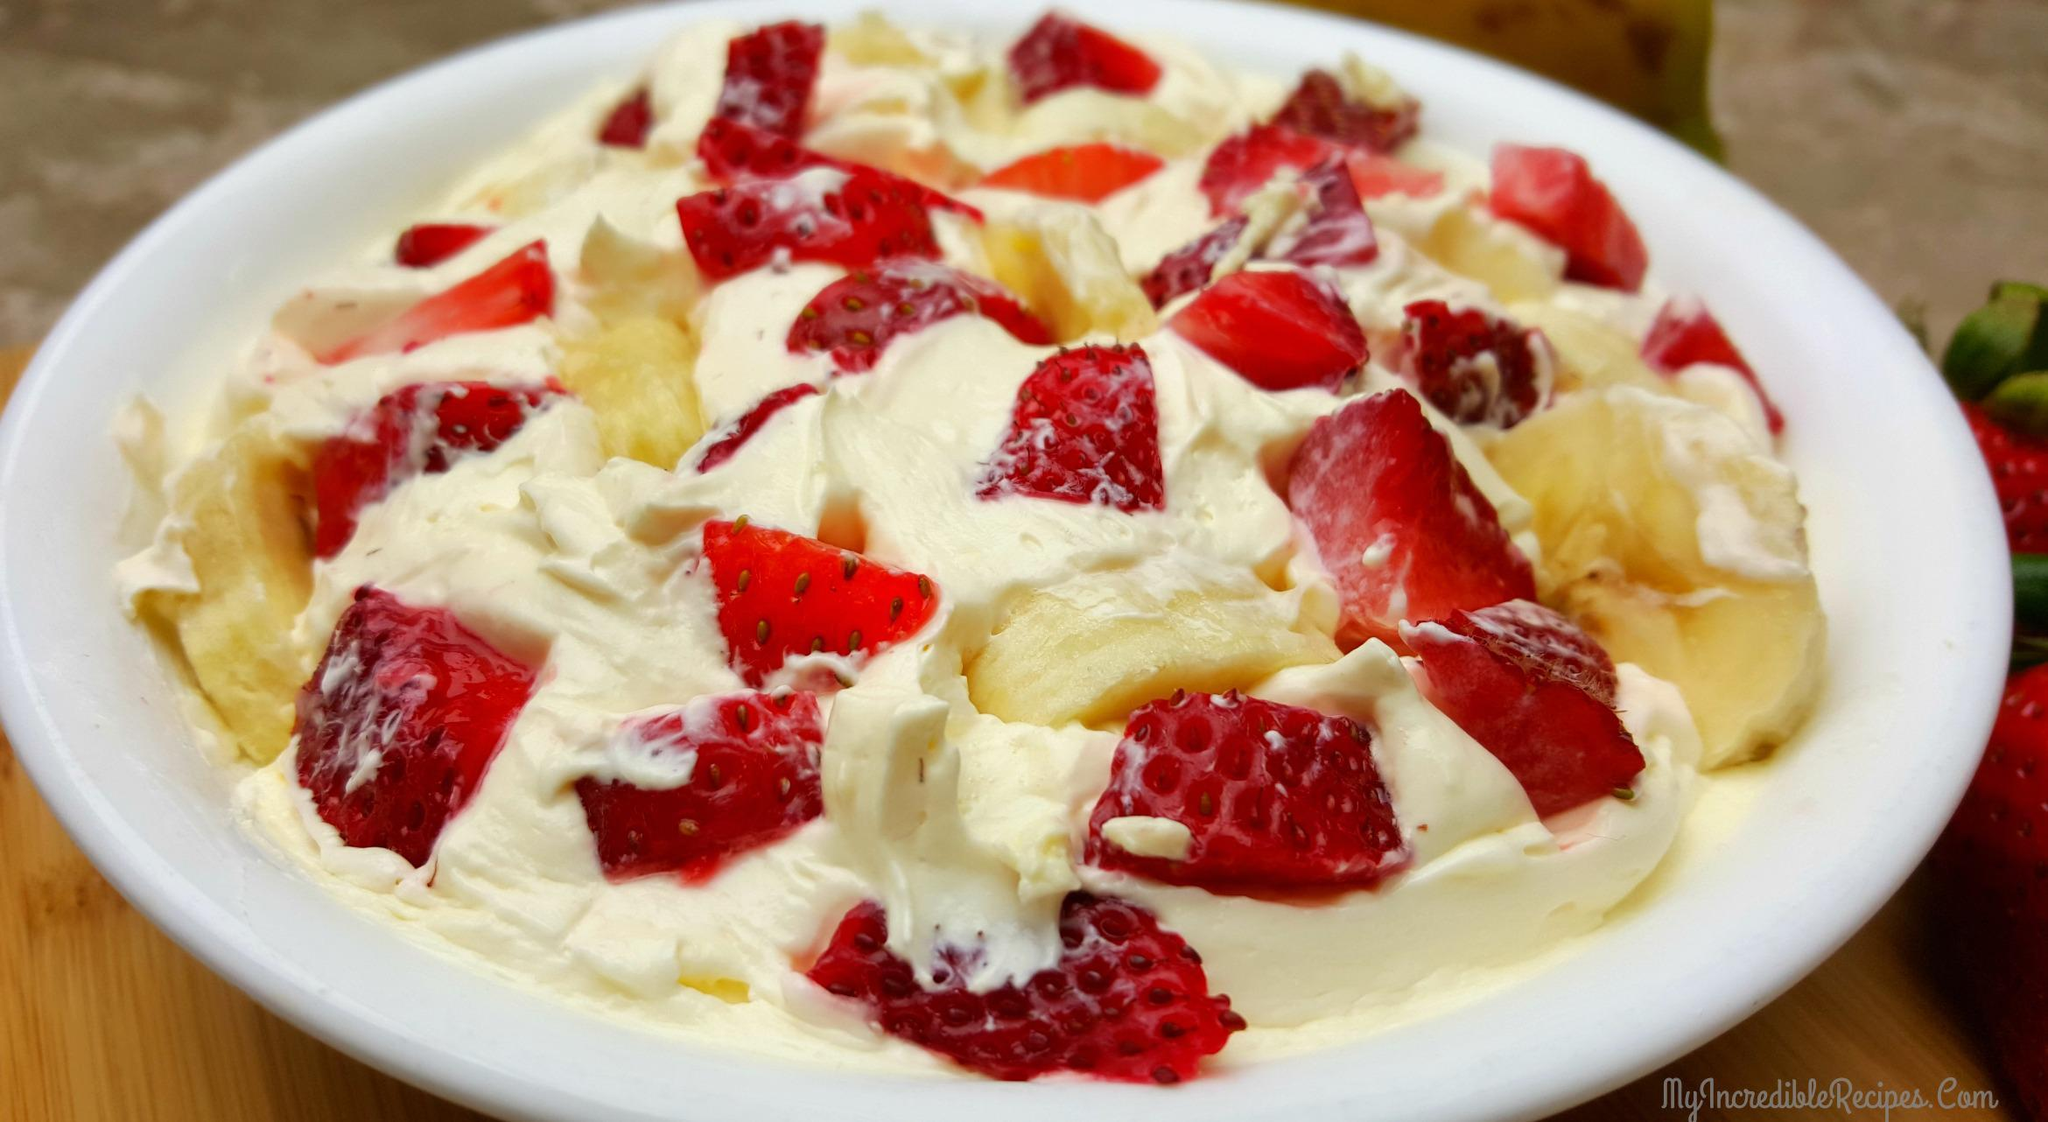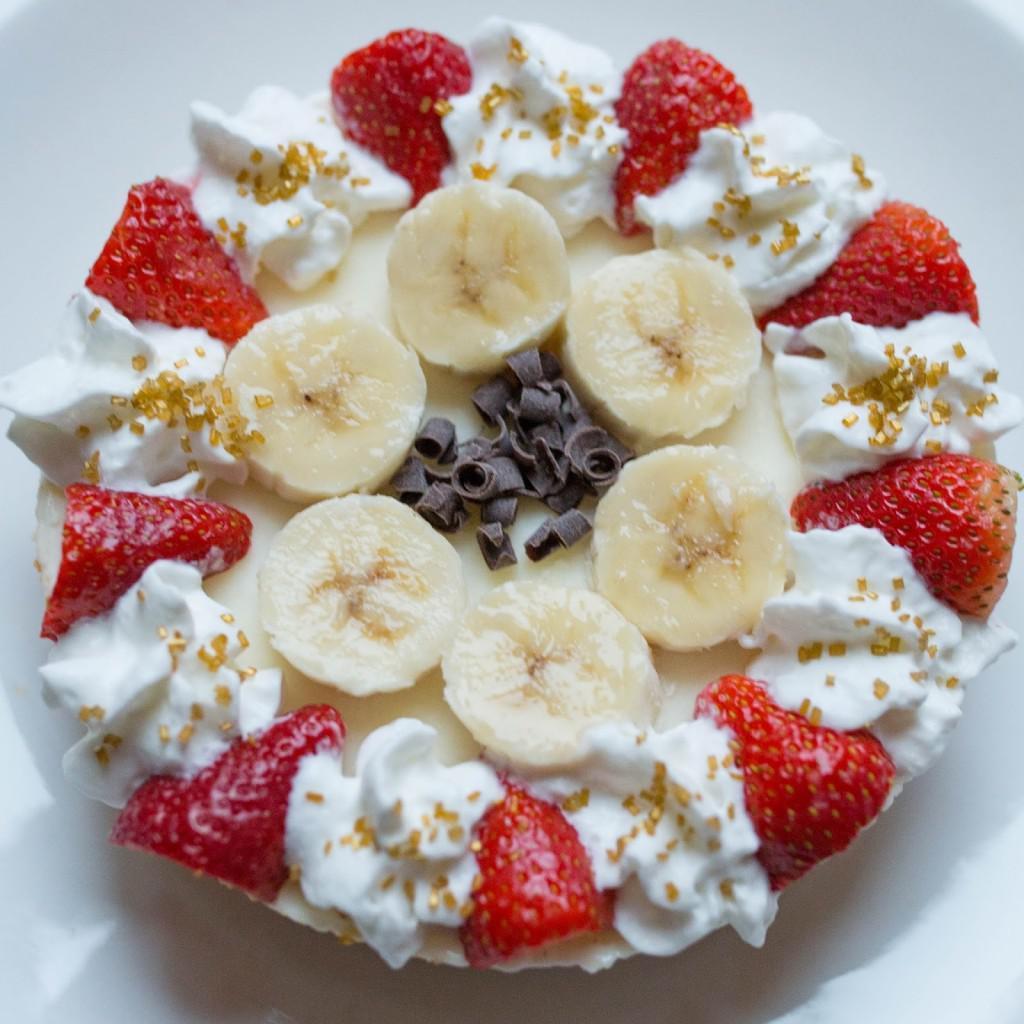The first image is the image on the left, the second image is the image on the right. Analyze the images presented: Is the assertion "There is cutlery outside of the bowl." valid? Answer yes or no. No. The first image is the image on the left, the second image is the image on the right. Assess this claim about the two images: "An image shows a round bowl of fruit dessert sitting on a wood-grain board, with a piece of silverware laying flat on the right side of the bowl.". Correct or not? Answer yes or no. No. 